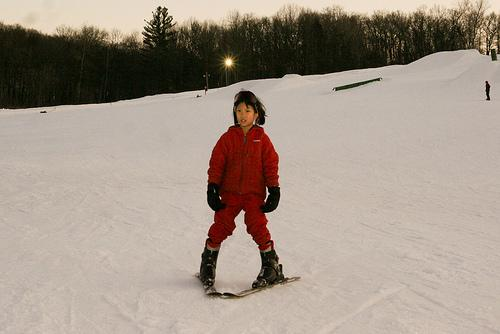What is the child standing on?

Choices:
A) grass
B) box
C) snow
D) sand snow 